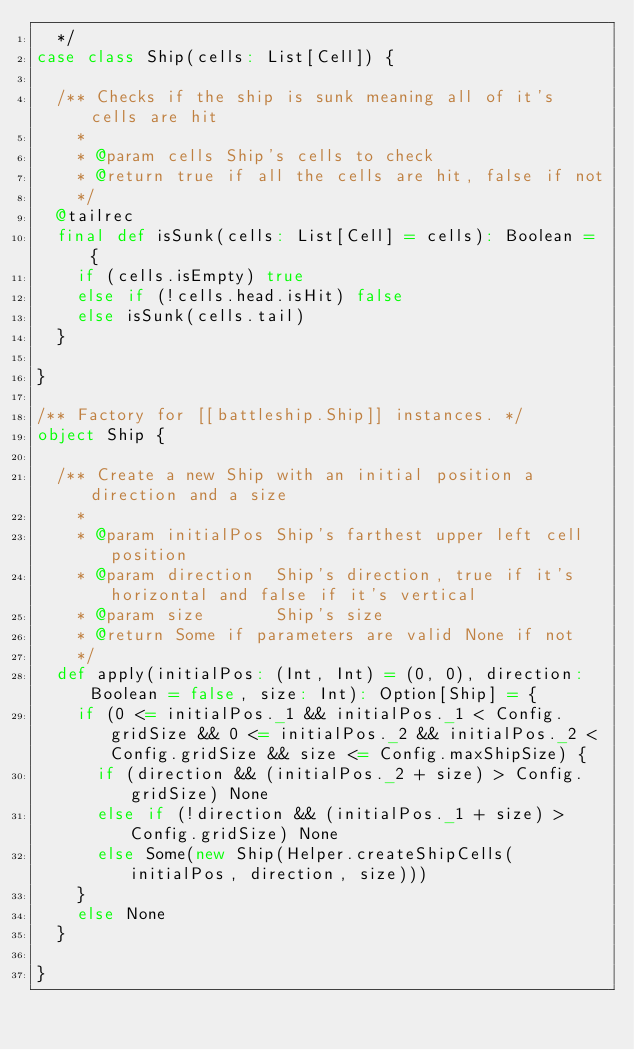<code> <loc_0><loc_0><loc_500><loc_500><_Scala_>  */
case class Ship(cells: List[Cell]) {

  /** Checks if the ship is sunk meaning all of it's cells are hit
    *
    * @param cells Ship's cells to check
    * @return true if all the cells are hit, false if not
    */
  @tailrec
  final def isSunk(cells: List[Cell] = cells): Boolean = {
    if (cells.isEmpty) true
    else if (!cells.head.isHit) false
    else isSunk(cells.tail)
  }

}

/** Factory for [[battleship.Ship]] instances. */
object Ship {

  /** Create a new Ship with an initial position a direction and a size
    *
    * @param initialPos Ship's farthest upper left cell position
    * @param direction  Ship's direction, true if it's horizontal and false if it's vertical
    * @param size       Ship's size
    * @return Some if parameters are valid None if not
    */
  def apply(initialPos: (Int, Int) = (0, 0), direction: Boolean = false, size: Int): Option[Ship] = {
    if (0 <= initialPos._1 && initialPos._1 < Config.gridSize && 0 <= initialPos._2 && initialPos._2 < Config.gridSize && size <= Config.maxShipSize) {
      if (direction && (initialPos._2 + size) > Config.gridSize) None
      else if (!direction && (initialPos._1 + size) > Config.gridSize) None
      else Some(new Ship(Helper.createShipCells(initialPos, direction, size)))
    }
    else None
  }

}</code> 